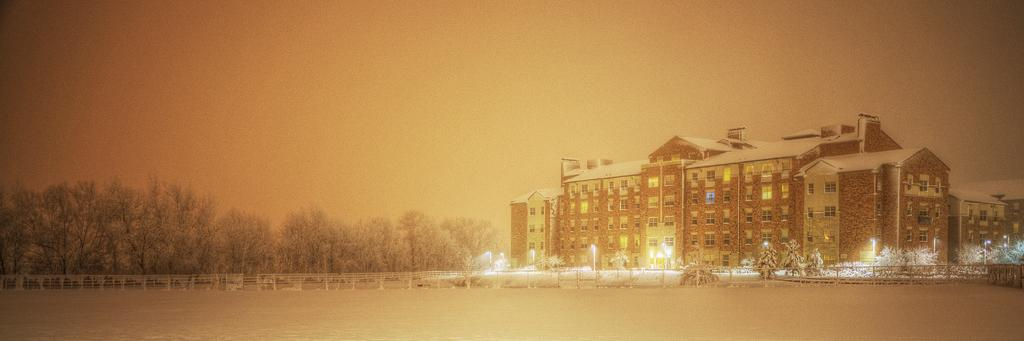What type of structures can be seen in the image? There are buildings in the image. What other natural elements are present in the image? There are trees in the image. What type of barrier can be seen in the image? There is a fence in the image. What type of lighting is present in the image? There are pole lights in the image. What can be seen in the background of the image? The sky is visible in the background of the image. Is there a wilderness area visible in the image? There is no wilderness area present in the image; it features buildings, trees, a fence, pole lights, and the sky. What route can be taken to reach the low area in the image? There is no low area mentioned in the image, and therefore no route can be determined. 